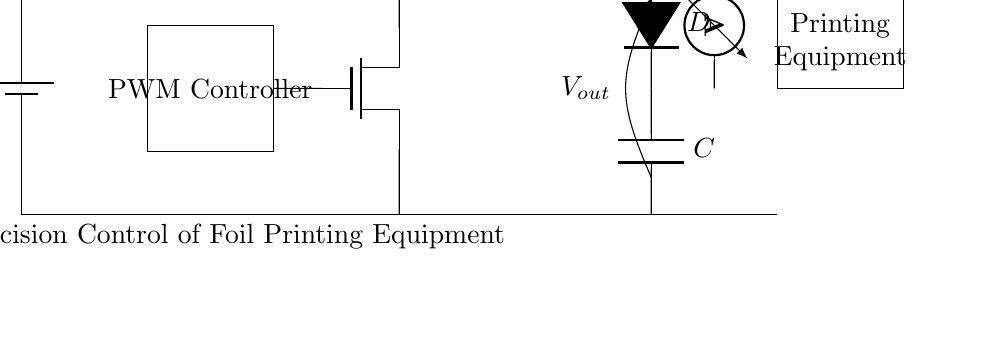What is the input voltage of the circuit? The input voltage, labeled as V_in, indicates the supply voltage connected to the circuit. This value can be inferred from the labeling on the battery symbol.
Answer: V_in What type of controller is used in this circuit? The controller responsible for managing the pulse width modulation is depicted as a rectangle labeled "PWM Controller" in the circuit diagram.
Answer: PWM Controller Which component ensures current flows in one direction only? The diode, labeled as D, is specifically designed to allow current to pass in one direction while preventing reverse current, which is a key characteristic of diodes.
Answer: Diode What is the function of the inductor in this circuit? The inductor, labeled as L, is used to store energy and smooth out current fluctuations in the charging process by resisting changes in current flow.
Answer: Energy storage How does the PWM controller affect the output voltage? The PWM Controller alters the output voltage by varying the duty cycle of the PWM signal, which directly influences how much time the MOSFET is turned on or off, affecting the average voltage applied to the load.
Answer: Duty cycle adjustment What is measured at the output of the circuit? The diagram includes an open terminal labeled V_out, indicating that the output voltage across this point is measured, giving a direct reading of the voltage supplied to the foil printing equipment.
Answer: V_out What is the primary load in the circuit? The load indicated in the circuit is labeled as "Foil Printing Equipment," which shows that the circuit is designed to provide power specifically to this type of machinery.
Answer: Foil Printing Equipment 